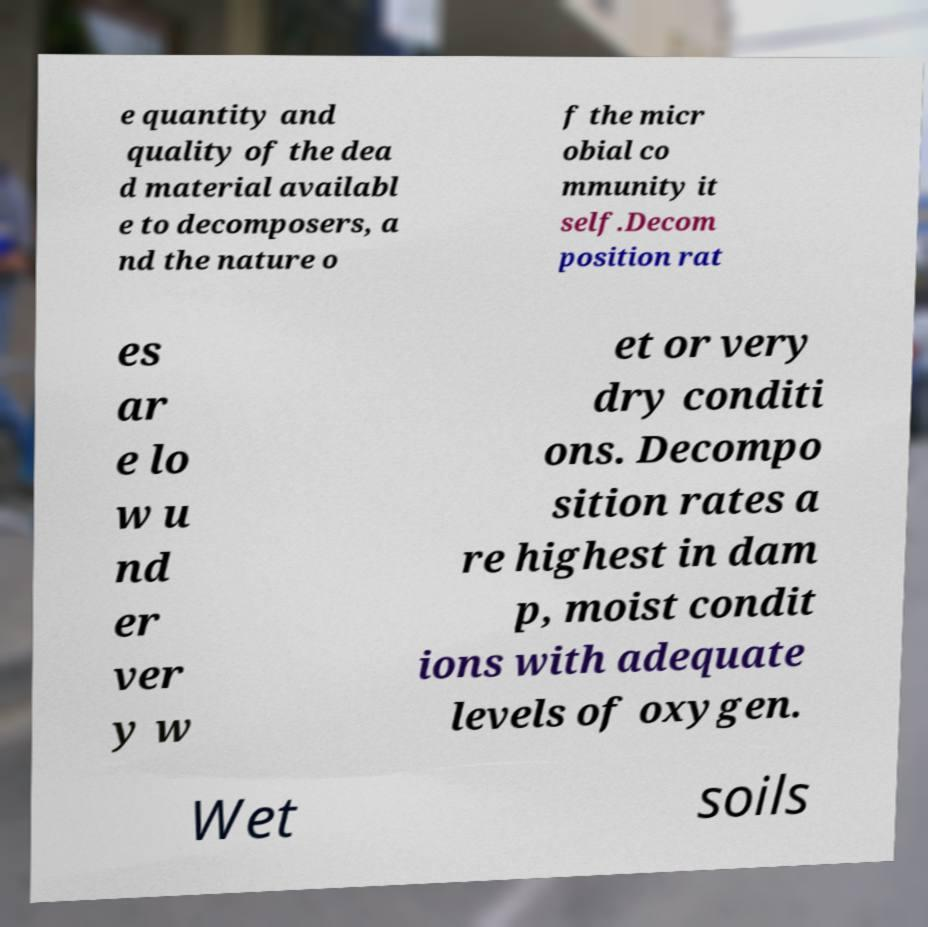For documentation purposes, I need the text within this image transcribed. Could you provide that? e quantity and quality of the dea d material availabl e to decomposers, a nd the nature o f the micr obial co mmunity it self.Decom position rat es ar e lo w u nd er ver y w et or very dry conditi ons. Decompo sition rates a re highest in dam p, moist condit ions with adequate levels of oxygen. Wet soils 